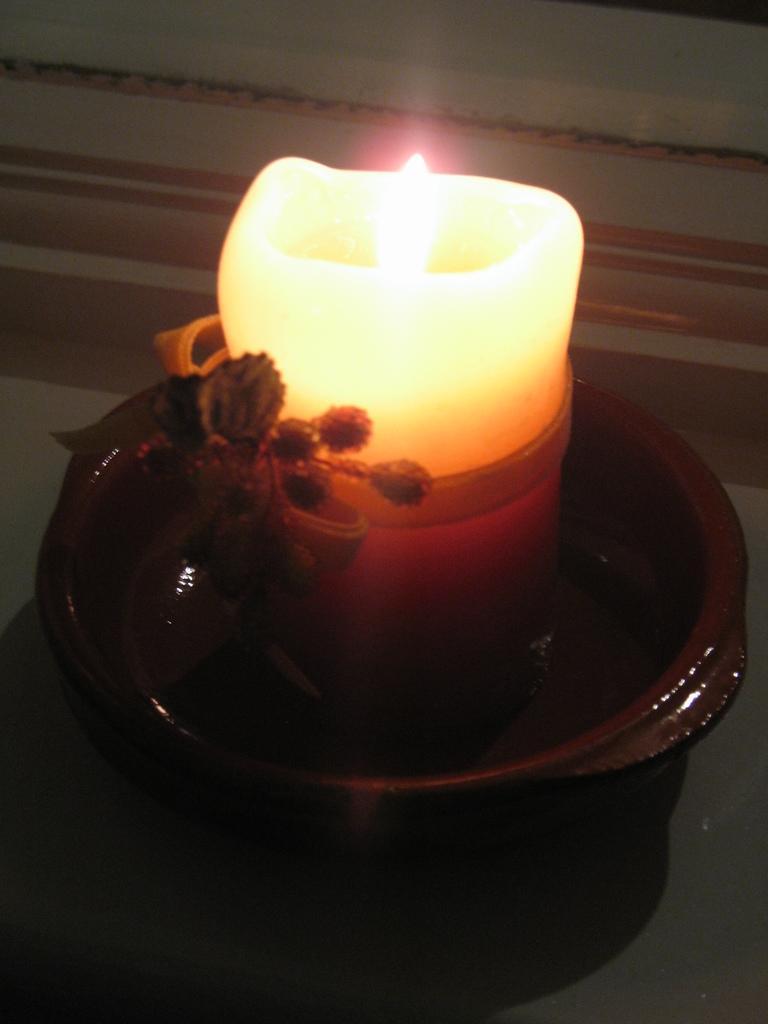Describe this image in one or two sentences. In this picture, we see a clay candle pot which is light, is placed on the white table. In the background, it is white in color. 